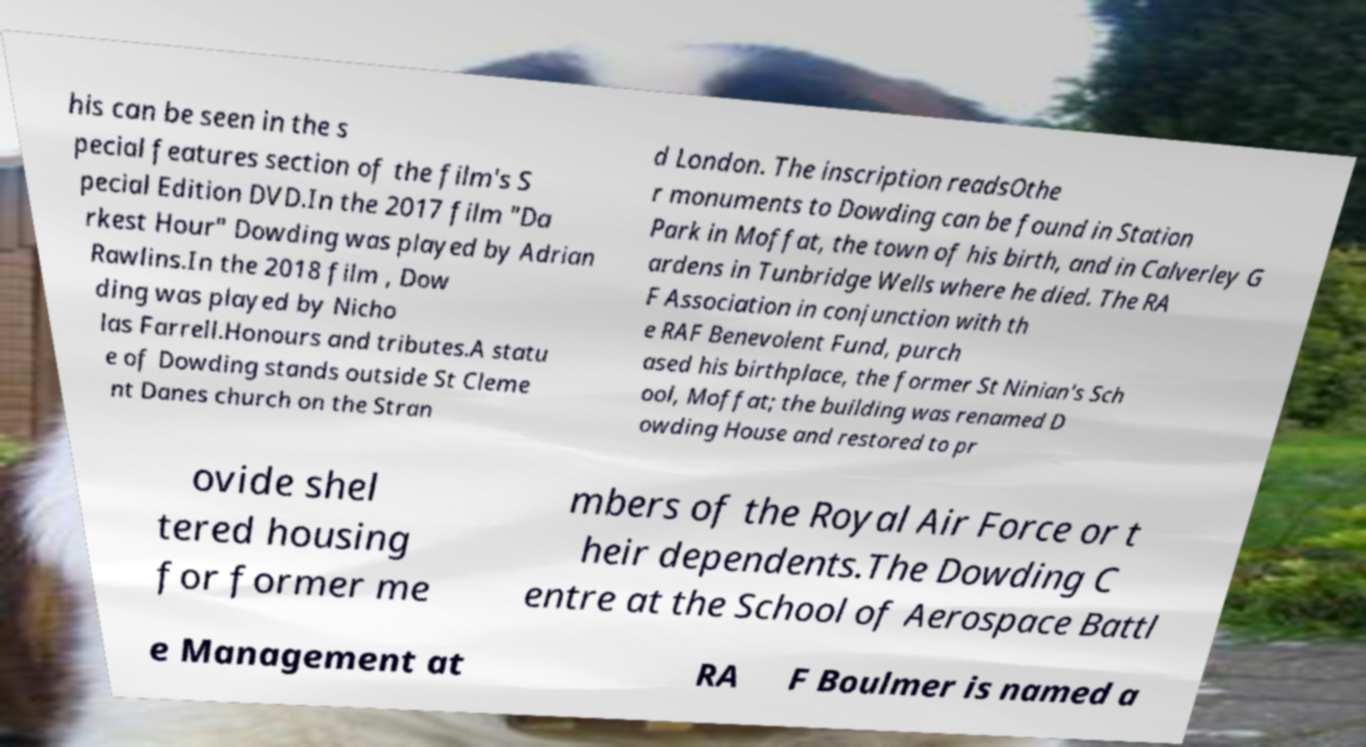Could you extract and type out the text from this image? his can be seen in the s pecial features section of the film's S pecial Edition DVD.In the 2017 film "Da rkest Hour" Dowding was played by Adrian Rawlins.In the 2018 film , Dow ding was played by Nicho las Farrell.Honours and tributes.A statu e of Dowding stands outside St Cleme nt Danes church on the Stran d London. The inscription readsOthe r monuments to Dowding can be found in Station Park in Moffat, the town of his birth, and in Calverley G ardens in Tunbridge Wells where he died. The RA F Association in conjunction with th e RAF Benevolent Fund, purch ased his birthplace, the former St Ninian's Sch ool, Moffat; the building was renamed D owding House and restored to pr ovide shel tered housing for former me mbers of the Royal Air Force or t heir dependents.The Dowding C entre at the School of Aerospace Battl e Management at RA F Boulmer is named a 